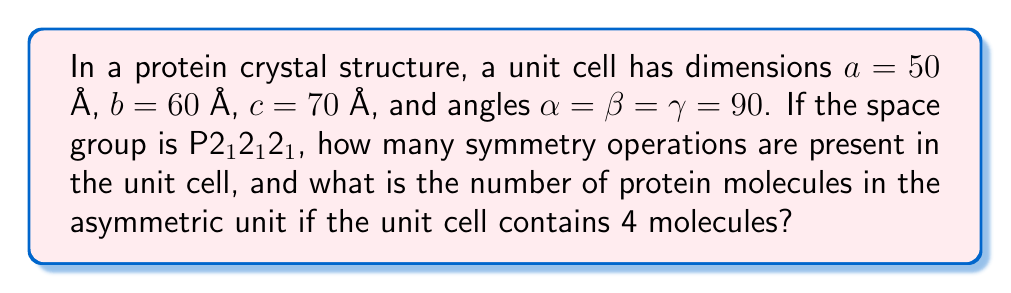Can you solve this math problem? To solve this problem, we need to follow these steps:

1. Identify the space group symmetry:
   The space group P2$_1$2$_1$2$_1$ belongs to the orthorhombic crystal system with three 2$_1$ screw axes along a, b, and c.

2. Calculate the number of symmetry operations:
   - The general formula for the number of symmetry operations is:
     $$ \text{Number of operations} = \frac{\text{Number of equivalent positions}}{\text{Multiplicity of the general position}} $$
   - For P2$_1$2$_1$2$_1$, there are 4 equivalent positions.
   - The multiplicity of the general position is 1.
   - Therefore, the number of symmetry operations is:
     $$ \text{Number of operations} = \frac{4}{1} = 4 $$

3. Determine the number of protein molecules in the asymmetric unit:
   - The number of molecules in the asymmetric unit is calculated by:
     $$ \text{Molecules in asymmetric unit} = \frac{\text{Total molecules in unit cell}}{\text{Number of symmetry operations}} $$
   - We are given that there are 4 molecules in the unit cell.
   - Therefore:
     $$ \text{Molecules in asymmetric unit} = \frac{4}{4} = 1 $$

Thus, there are 4 symmetry operations in the unit cell, and 1 protein molecule in the asymmetric unit.
Answer: 4 symmetry operations; 1 molecule in the asymmetric unit 